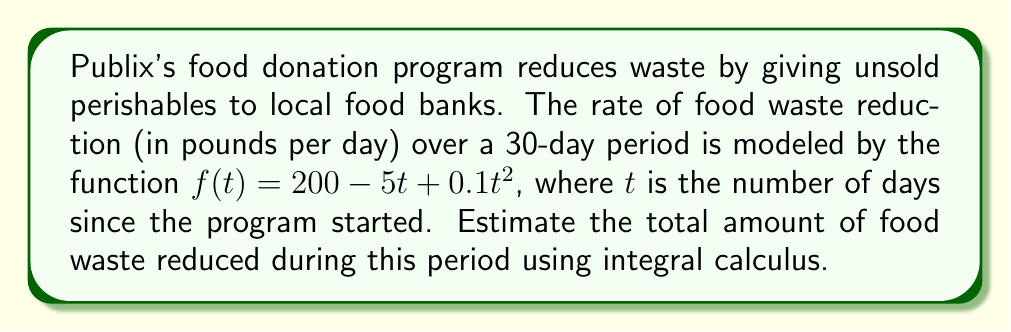Can you answer this question? To estimate the total amount of food waste reduced, we need to calculate the area under the curve of the given function over the 30-day period. This can be done using a definite integral.

Step 1: Set up the definite integral
$$\int_0^{30} (200 - 5t + 0.1t^2) dt$$

Step 2: Integrate the function
$$\int (200 - 5t + 0.1t^2) dt = 200t - \frac{5t^2}{2} + \frac{0.1t^3}{3} + C$$

Step 3: Apply the limits of integration
$$\left[200t - \frac{5t^2}{2} + \frac{0.1t^3}{3}\right]_0^{30}$$

Step 4: Calculate the result
$$\left(200(30) - \frac{5(30)^2}{2} + \frac{0.1(30)^3}{3}\right) - \left(200(0) - \frac{5(0)^2}{2} + \frac{0.1(0)^3}{3}\right)$$
$$= \left(6000 - 2250 + 900\right) - 0$$
$$= 4650$$

Therefore, the estimated total amount of food waste reduced during the 30-day period is 4650 pounds.
Answer: 4650 pounds 